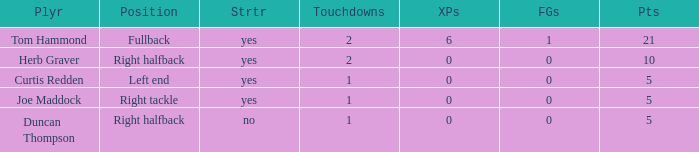Name the starter for position being left end Yes. 